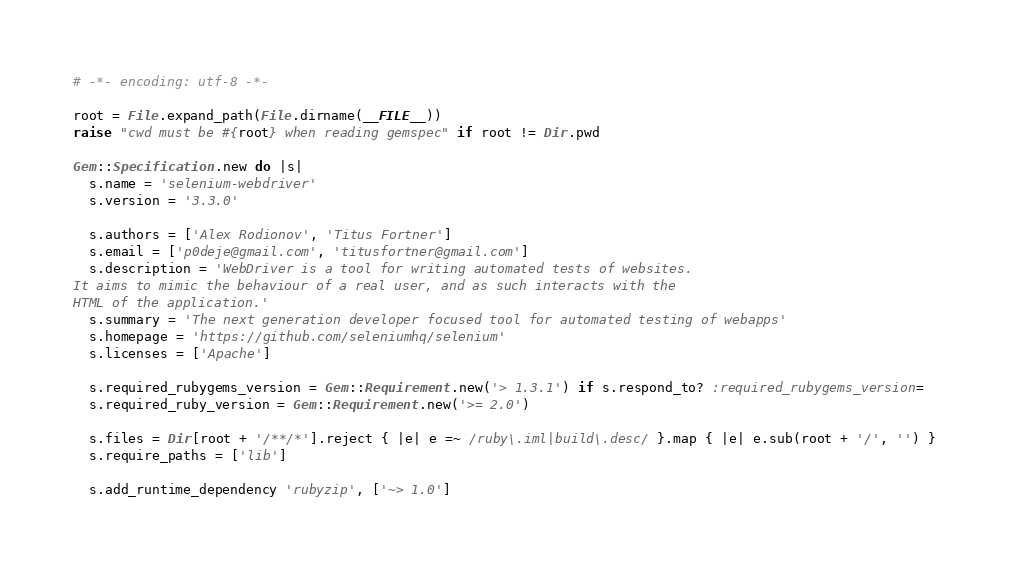Convert code to text. <code><loc_0><loc_0><loc_500><loc_500><_Ruby_># -*- encoding: utf-8 -*-

root = File.expand_path(File.dirname(__FILE__))
raise "cwd must be #{root} when reading gemspec" if root != Dir.pwd

Gem::Specification.new do |s|
  s.name = 'selenium-webdriver'
  s.version = '3.3.0'

  s.authors = ['Alex Rodionov', 'Titus Fortner']
  s.email = ['p0deje@gmail.com', 'titusfortner@gmail.com']
  s.description = 'WebDriver is a tool for writing automated tests of websites.
It aims to mimic the behaviour of a real user, and as such interacts with the
HTML of the application.'
  s.summary = 'The next generation developer focused tool for automated testing of webapps'
  s.homepage = 'https://github.com/seleniumhq/selenium'
  s.licenses = ['Apache']

  s.required_rubygems_version = Gem::Requirement.new('> 1.3.1') if s.respond_to? :required_rubygems_version=
  s.required_ruby_version = Gem::Requirement.new('>= 2.0')

  s.files = Dir[root + '/**/*'].reject { |e| e =~ /ruby\.iml|build\.desc/ }.map { |e| e.sub(root + '/', '') }
  s.require_paths = ['lib']

  s.add_runtime_dependency 'rubyzip', ['~> 1.0']</code> 